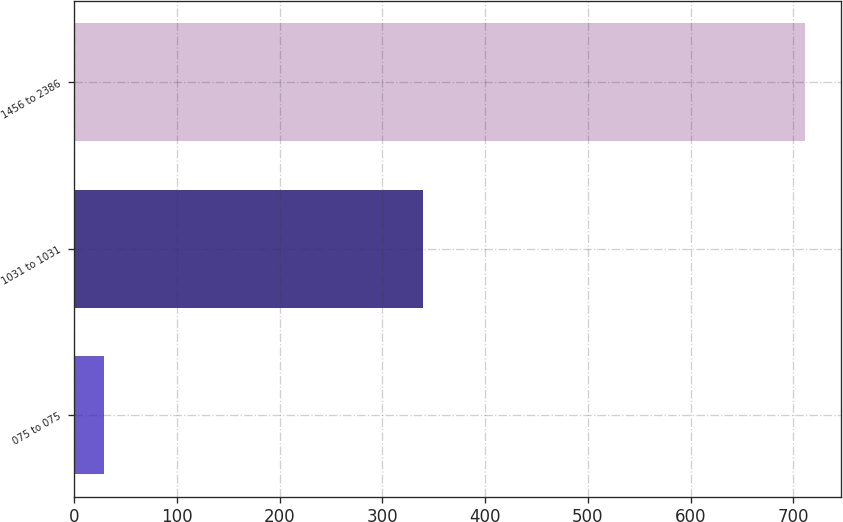<chart> <loc_0><loc_0><loc_500><loc_500><bar_chart><fcel>075 to 075<fcel>1031 to 1031<fcel>1456 to 2386<nl><fcel>29<fcel>340<fcel>711<nl></chart> 